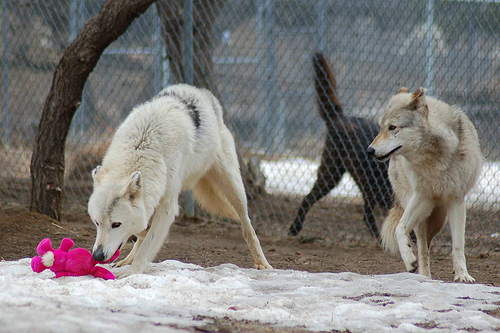<image>
Is the fox on the toy? Yes. Looking at the image, I can see the fox is positioned on top of the toy, with the toy providing support. Is there a stuffed rabbit in the wolf? No. The stuffed rabbit is not contained within the wolf. These objects have a different spatial relationship. Is there a toy next to the dog? Yes. The toy is positioned adjacent to the dog, located nearby in the same general area. Is the wolf above the snow? Yes. The wolf is positioned above the snow in the vertical space, higher up in the scene. 